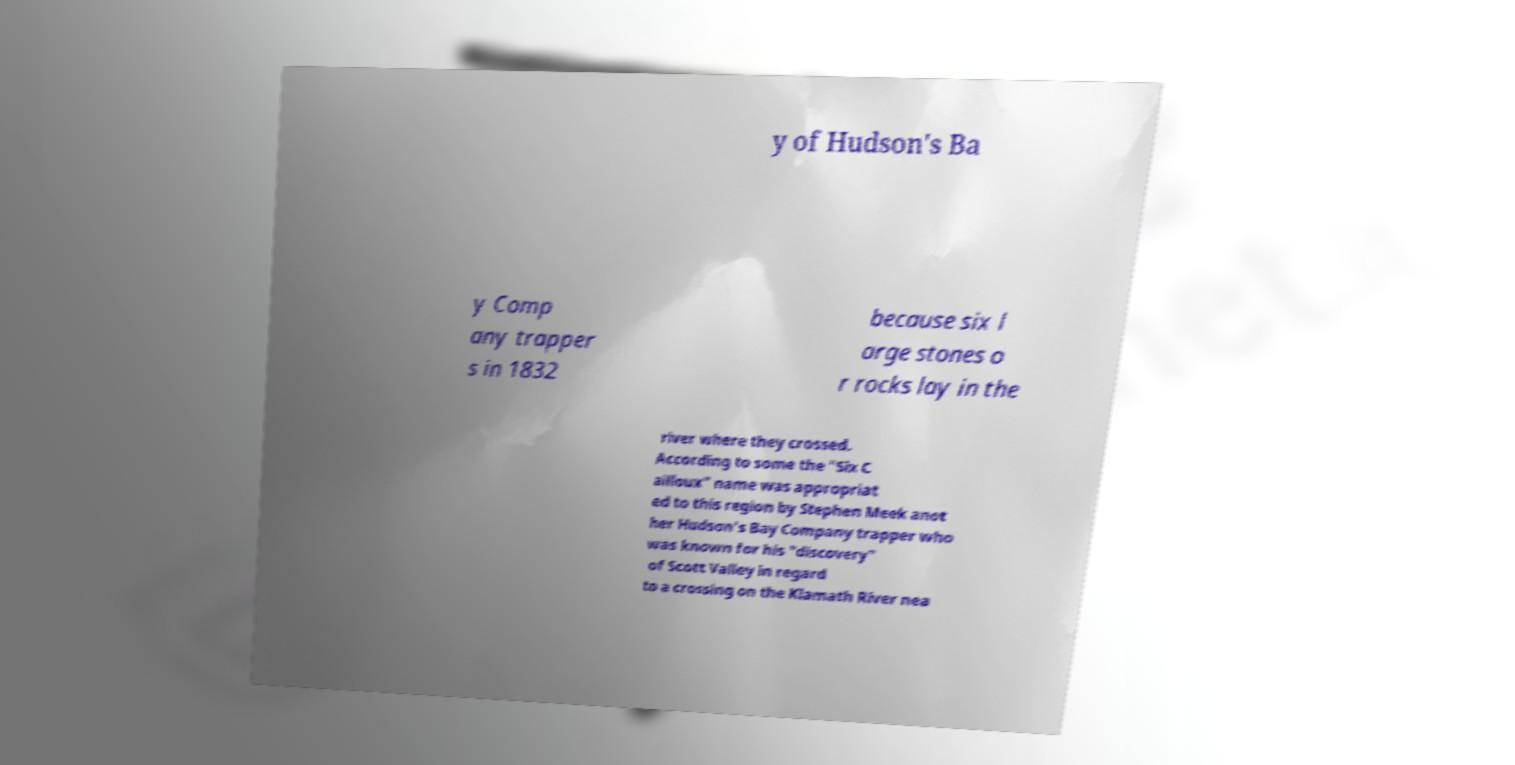Can you read and provide the text displayed in the image?This photo seems to have some interesting text. Can you extract and type it out for me? y of Hudson's Ba y Comp any trapper s in 1832 because six l arge stones o r rocks lay in the river where they crossed. According to some the "Six C ailloux" name was appropriat ed to this region by Stephen Meek anot her Hudson's Bay Company trapper who was known for his "discovery" of Scott Valley in regard to a crossing on the Klamath River nea 